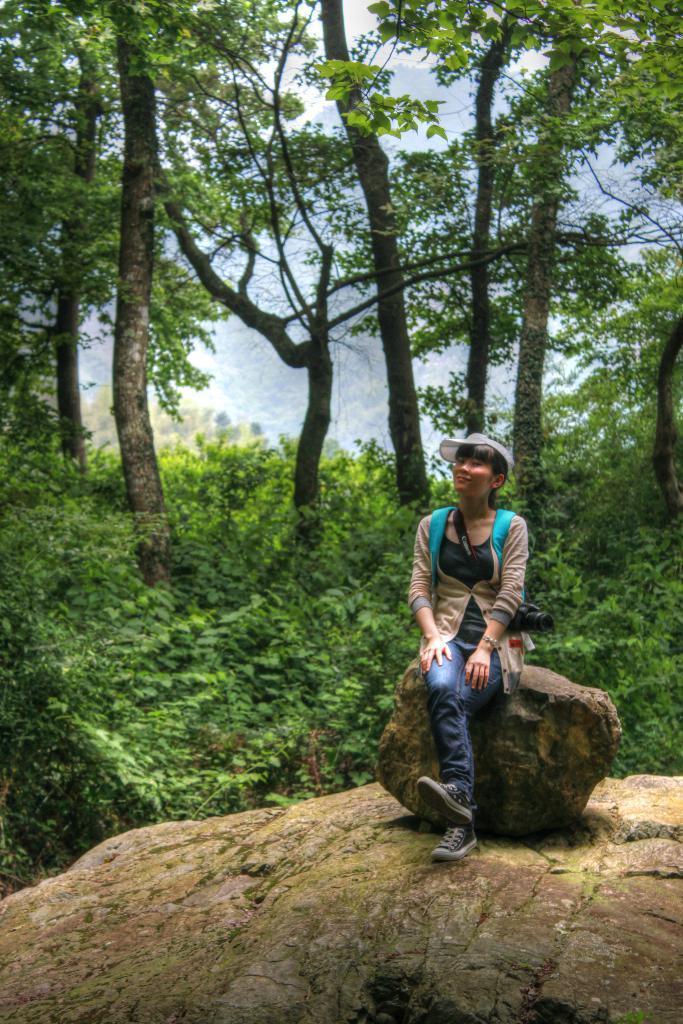How would you summarize this image in a sentence or two? In the center of the image there is a woman sitting on a stone. In the background of the image there are trees and plants. 